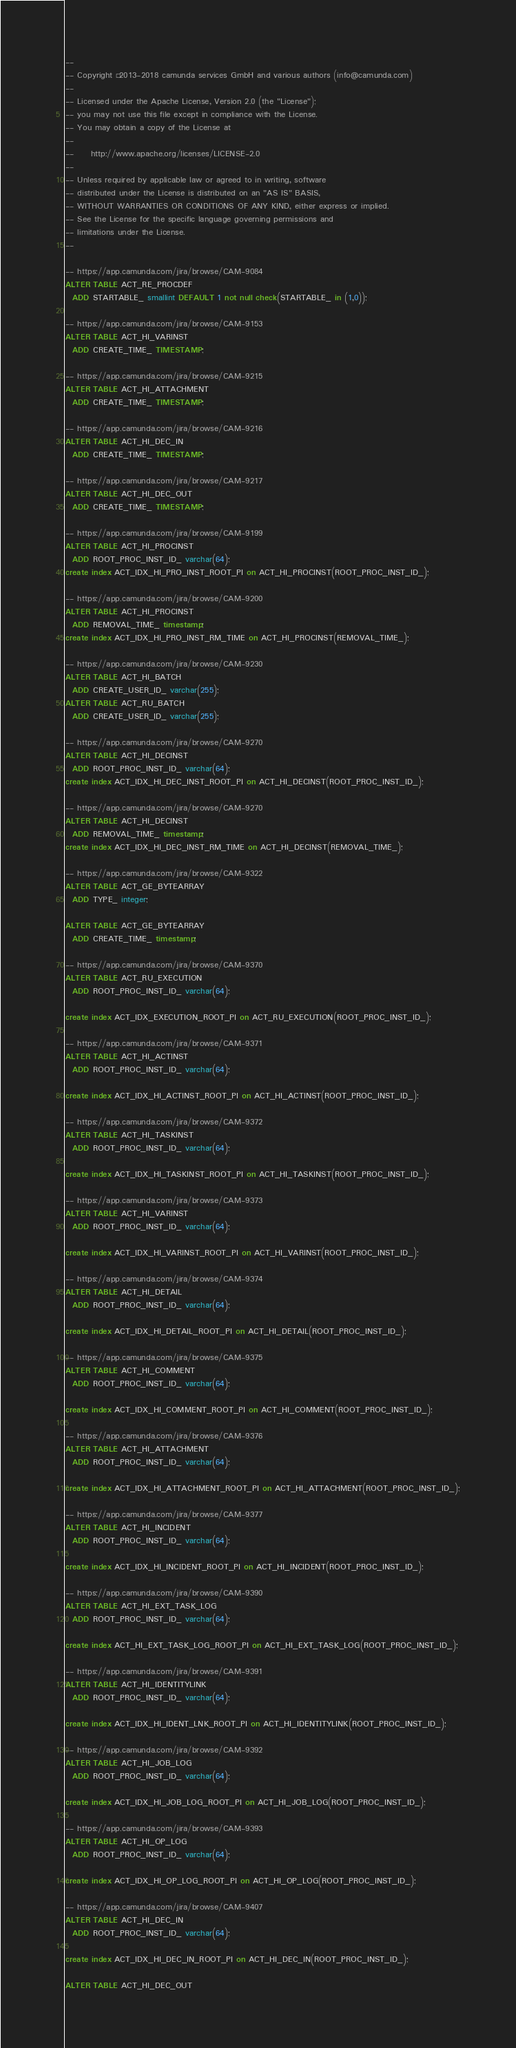Convert code to text. <code><loc_0><loc_0><loc_500><loc_500><_SQL_>--
-- Copyright © 2013-2018 camunda services GmbH and various authors (info@camunda.com)
--
-- Licensed under the Apache License, Version 2.0 (the "License");
-- you may not use this file except in compliance with the License.
-- You may obtain a copy of the License at
--
--     http://www.apache.org/licenses/LICENSE-2.0
--
-- Unless required by applicable law or agreed to in writing, software
-- distributed under the License is distributed on an "AS IS" BASIS,
-- WITHOUT WARRANTIES OR CONDITIONS OF ANY KIND, either express or implied.
-- See the License for the specific language governing permissions and
-- limitations under the License.
--

-- https://app.camunda.com/jira/browse/CAM-9084
ALTER TABLE ACT_RE_PROCDEF
  ADD STARTABLE_ smallint DEFAULT 1 not null check(STARTABLE_ in (1,0));

-- https://app.camunda.com/jira/browse/CAM-9153
ALTER TABLE ACT_HI_VARINST
  ADD CREATE_TIME_ TIMESTAMP;

-- https://app.camunda.com/jira/browse/CAM-9215
ALTER TABLE ACT_HI_ATTACHMENT
  ADD CREATE_TIME_ TIMESTAMP;

-- https://app.camunda.com/jira/browse/CAM-9216
ALTER TABLE ACT_HI_DEC_IN
  ADD CREATE_TIME_ TIMESTAMP;

-- https://app.camunda.com/jira/browse/CAM-9217
ALTER TABLE ACT_HI_DEC_OUT
  ADD CREATE_TIME_ TIMESTAMP;

-- https://app.camunda.com/jira/browse/CAM-9199
ALTER TABLE ACT_HI_PROCINST
  ADD ROOT_PROC_INST_ID_ varchar(64);
create index ACT_IDX_HI_PRO_INST_ROOT_PI on ACT_HI_PROCINST(ROOT_PROC_INST_ID_);

-- https://app.camunda.com/jira/browse/CAM-9200
ALTER TABLE ACT_HI_PROCINST
  ADD REMOVAL_TIME_ timestamp;
create index ACT_IDX_HI_PRO_INST_RM_TIME on ACT_HI_PROCINST(REMOVAL_TIME_);

-- https://app.camunda.com/jira/browse/CAM-9230
ALTER TABLE ACT_HI_BATCH
  ADD CREATE_USER_ID_ varchar(255);
ALTER TABLE ACT_RU_BATCH
  ADD CREATE_USER_ID_ varchar(255);

-- https://app.camunda.com/jira/browse/CAM-9270
ALTER TABLE ACT_HI_DECINST
  ADD ROOT_PROC_INST_ID_ varchar(64);
create index ACT_IDX_HI_DEC_INST_ROOT_PI on ACT_HI_DECINST(ROOT_PROC_INST_ID_);

-- https://app.camunda.com/jira/browse/CAM-9270
ALTER TABLE ACT_HI_DECINST
  ADD REMOVAL_TIME_ timestamp;
create index ACT_IDX_HI_DEC_INST_RM_TIME on ACT_HI_DECINST(REMOVAL_TIME_);

-- https://app.camunda.com/jira/browse/CAM-9322
ALTER TABLE ACT_GE_BYTEARRAY
  ADD TYPE_ integer;

ALTER TABLE ACT_GE_BYTEARRAY
  ADD CREATE_TIME_ timestamp;

-- https://app.camunda.com/jira/browse/CAM-9370
ALTER TABLE ACT_RU_EXECUTION
  ADD ROOT_PROC_INST_ID_ varchar(64);

create index ACT_IDX_EXECUTION_ROOT_PI on ACT_RU_EXECUTION(ROOT_PROC_INST_ID_);

-- https://app.camunda.com/jira/browse/CAM-9371
ALTER TABLE ACT_HI_ACTINST
  ADD ROOT_PROC_INST_ID_ varchar(64);

create index ACT_IDX_HI_ACTINST_ROOT_PI on ACT_HI_ACTINST(ROOT_PROC_INST_ID_);

-- https://app.camunda.com/jira/browse/CAM-9372
ALTER TABLE ACT_HI_TASKINST
  ADD ROOT_PROC_INST_ID_ varchar(64);

create index ACT_IDX_HI_TASKINST_ROOT_PI on ACT_HI_TASKINST(ROOT_PROC_INST_ID_);

-- https://app.camunda.com/jira/browse/CAM-9373
ALTER TABLE ACT_HI_VARINST
  ADD ROOT_PROC_INST_ID_ varchar(64);

create index ACT_IDX_HI_VARINST_ROOT_PI on ACT_HI_VARINST(ROOT_PROC_INST_ID_);

-- https://app.camunda.com/jira/browse/CAM-9374
ALTER TABLE ACT_HI_DETAIL
  ADD ROOT_PROC_INST_ID_ varchar(64);

create index ACT_IDX_HI_DETAIL_ROOT_PI on ACT_HI_DETAIL(ROOT_PROC_INST_ID_);

-- https://app.camunda.com/jira/browse/CAM-9375
ALTER TABLE ACT_HI_COMMENT
  ADD ROOT_PROC_INST_ID_ varchar(64);

create index ACT_IDX_HI_COMMENT_ROOT_PI on ACT_HI_COMMENT(ROOT_PROC_INST_ID_);

-- https://app.camunda.com/jira/browse/CAM-9376
ALTER TABLE ACT_HI_ATTACHMENT
  ADD ROOT_PROC_INST_ID_ varchar(64);

create index ACT_IDX_HI_ATTACHMENT_ROOT_PI on ACT_HI_ATTACHMENT(ROOT_PROC_INST_ID_);

-- https://app.camunda.com/jira/browse/CAM-9377
ALTER TABLE ACT_HI_INCIDENT
  ADD ROOT_PROC_INST_ID_ varchar(64);

create index ACT_IDX_HI_INCIDENT_ROOT_PI on ACT_HI_INCIDENT(ROOT_PROC_INST_ID_);

-- https://app.camunda.com/jira/browse/CAM-9390
ALTER TABLE ACT_HI_EXT_TASK_LOG
  ADD ROOT_PROC_INST_ID_ varchar(64);

create index ACT_HI_EXT_TASK_LOG_ROOT_PI on ACT_HI_EXT_TASK_LOG(ROOT_PROC_INST_ID_);

-- https://app.camunda.com/jira/browse/CAM-9391
ALTER TABLE ACT_HI_IDENTITYLINK
  ADD ROOT_PROC_INST_ID_ varchar(64);

create index ACT_IDX_HI_IDENT_LNK_ROOT_PI on ACT_HI_IDENTITYLINK(ROOT_PROC_INST_ID_);

-- https://app.camunda.com/jira/browse/CAM-9392
ALTER TABLE ACT_HI_JOB_LOG
  ADD ROOT_PROC_INST_ID_ varchar(64);

create index ACT_IDX_HI_JOB_LOG_ROOT_PI on ACT_HI_JOB_LOG(ROOT_PROC_INST_ID_);

-- https://app.camunda.com/jira/browse/CAM-9393
ALTER TABLE ACT_HI_OP_LOG
  ADD ROOT_PROC_INST_ID_ varchar(64);

create index ACT_IDX_HI_OP_LOG_ROOT_PI on ACT_HI_OP_LOG(ROOT_PROC_INST_ID_);

-- https://app.camunda.com/jira/browse/CAM-9407
ALTER TABLE ACT_HI_DEC_IN
  ADD ROOT_PROC_INST_ID_ varchar(64);

create index ACT_IDX_HI_DEC_IN_ROOT_PI on ACT_HI_DEC_IN(ROOT_PROC_INST_ID_);

ALTER TABLE ACT_HI_DEC_OUT</code> 